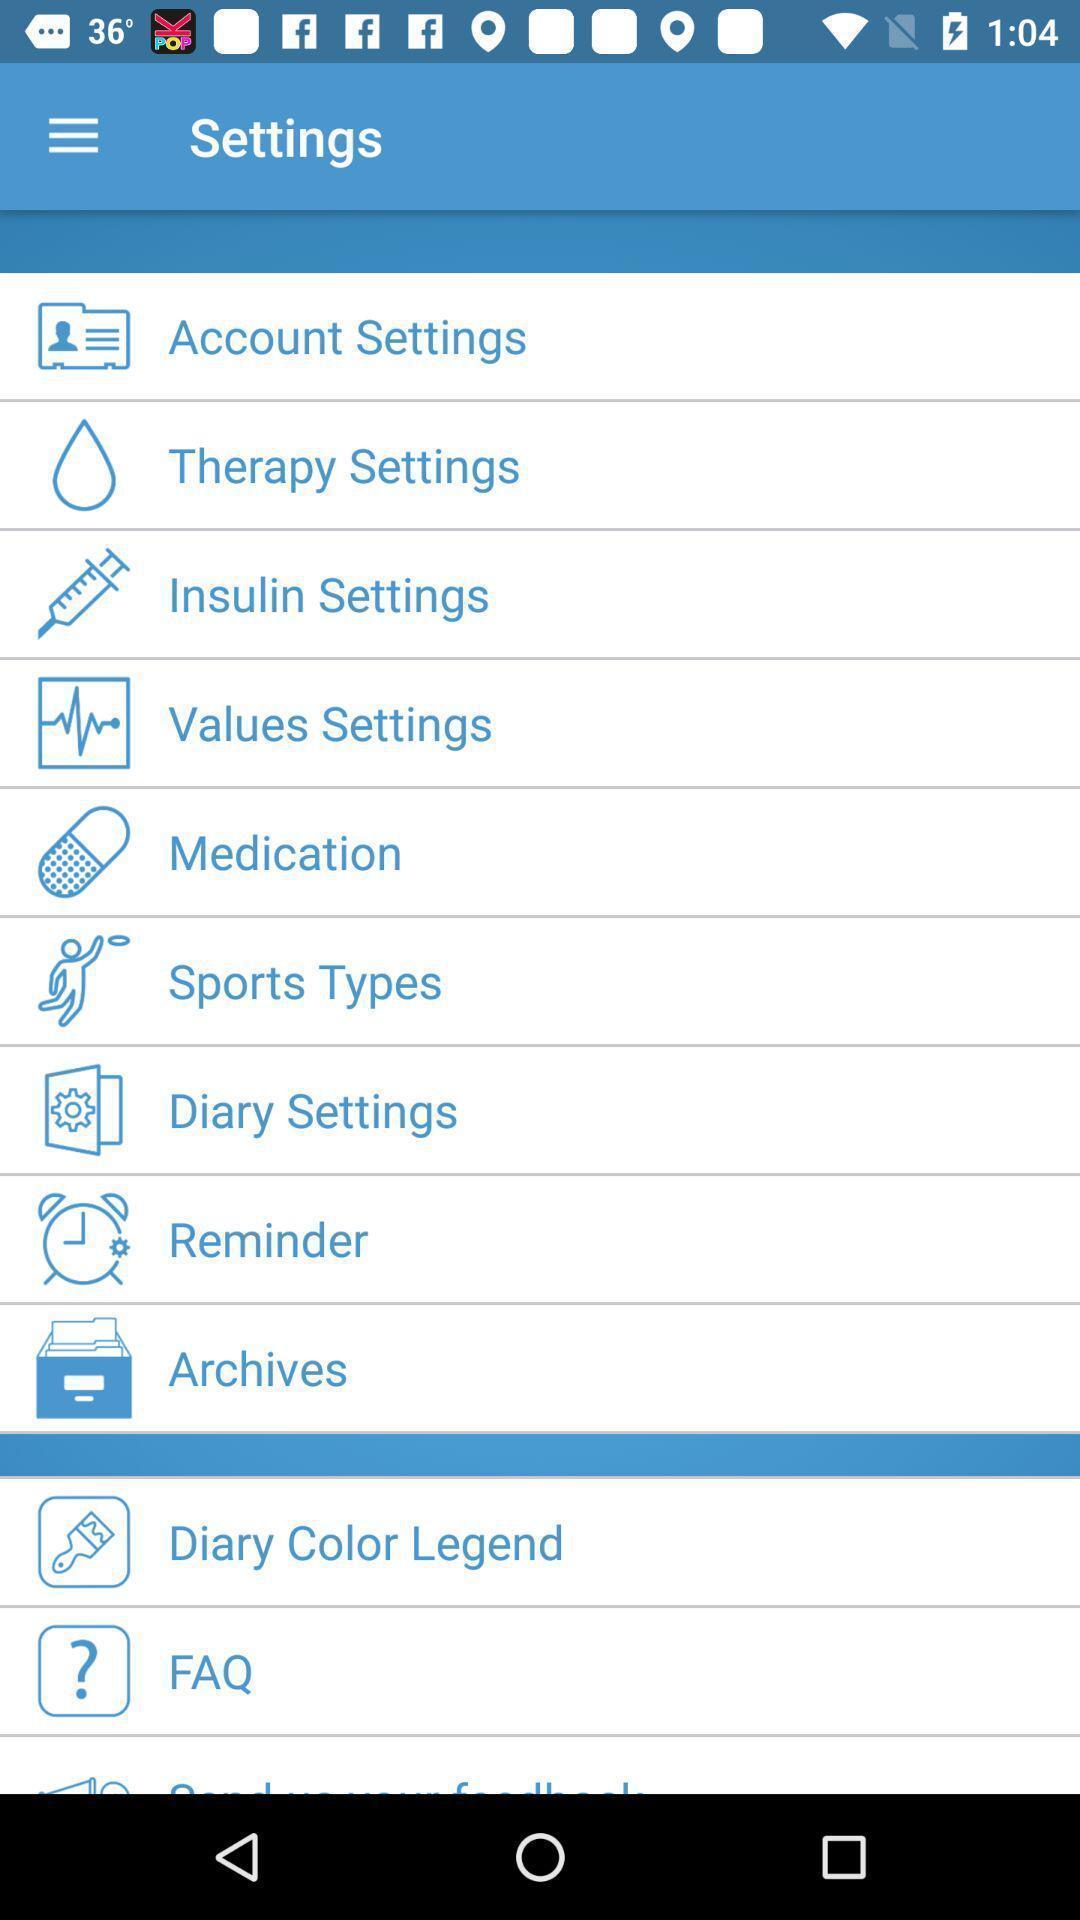Tell me what you see in this picture. Settings page. 